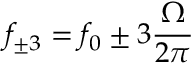<formula> <loc_0><loc_0><loc_500><loc_500>f _ { \pm 3 } = f _ { 0 } \pm 3 \frac { \Omega } { 2 \pi }</formula> 